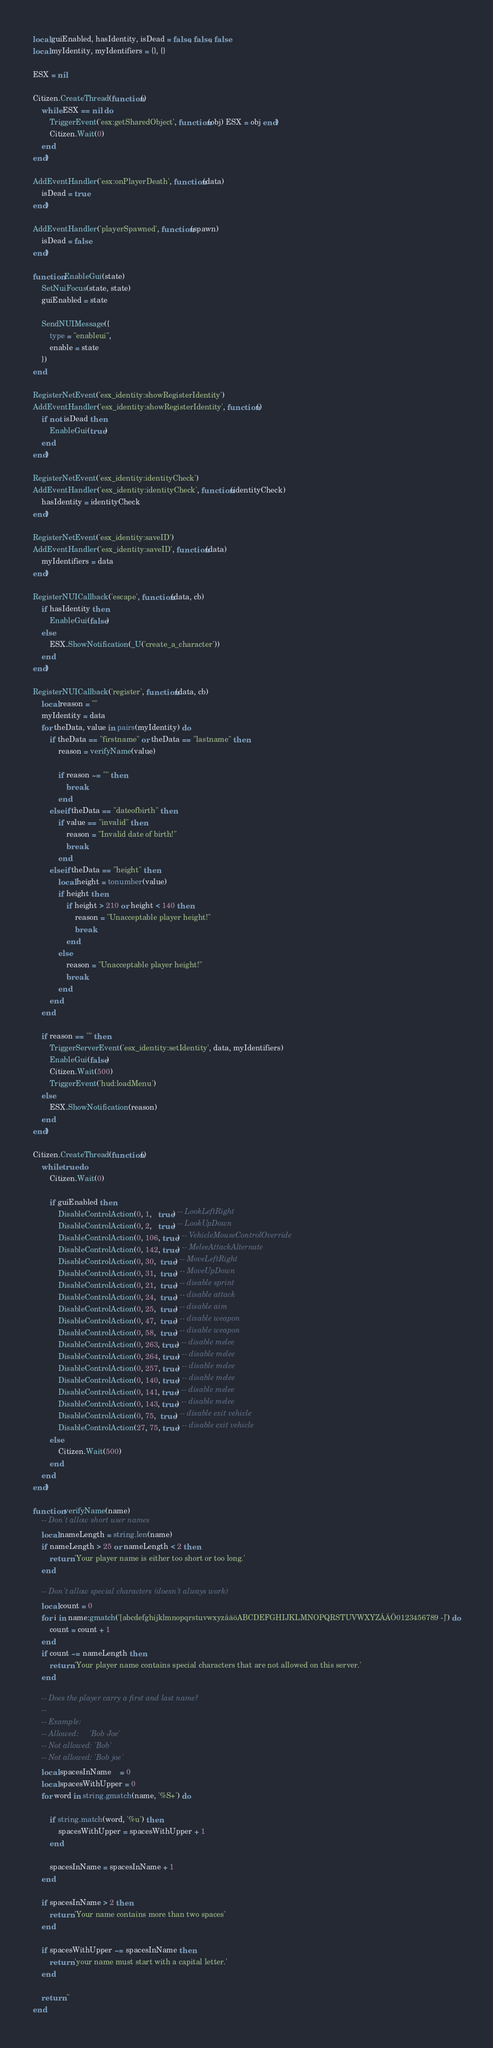<code> <loc_0><loc_0><loc_500><loc_500><_Lua_>local guiEnabled, hasIdentity, isDead = false, false, false
local myIdentity, myIdentifiers = {}, {}

ESX = nil

Citizen.CreateThread(function()
	while ESX == nil do
		TriggerEvent('esx:getSharedObject', function(obj) ESX = obj end)
		Citizen.Wait(0)
	end
end)

AddEventHandler('esx:onPlayerDeath', function(data)
	isDead = true
end)

AddEventHandler('playerSpawned', function(spawn)
	isDead = false
end)

function EnableGui(state)
	SetNuiFocus(state, state)
	guiEnabled = state

	SendNUIMessage({
		type = "enableui",
		enable = state
	})
end

RegisterNetEvent('esx_identity:showRegisterIdentity')
AddEventHandler('esx_identity:showRegisterIdentity', function()
	if not isDead then
		EnableGui(true)
	end
end)

RegisterNetEvent('esx_identity:identityCheck')
AddEventHandler('esx_identity:identityCheck', function(identityCheck)
	hasIdentity = identityCheck
end)

RegisterNetEvent('esx_identity:saveID')
AddEventHandler('esx_identity:saveID', function(data)
	myIdentifiers = data
end)

RegisterNUICallback('escape', function(data, cb)
	if hasIdentity then
		EnableGui(false)
	else
		ESX.ShowNotification(_U('create_a_character'))
	end
end)

RegisterNUICallback('register', function(data, cb)
	local reason = ""
	myIdentity = data
	for theData, value in pairs(myIdentity) do
		if theData == "firstname" or theData == "lastname" then
			reason = verifyName(value)
			
			if reason ~= "" then
				break
			end
		elseif theData == "dateofbirth" then
			if value == "invalid" then
				reason = "Invalid date of birth!"
				break
			end
		elseif theData == "height" then
			local height = tonumber(value)
			if height then
				if height > 210 or height < 140 then
					reason = "Unacceptable player height!"
					break
				end
			else
				reason = "Unacceptable player height!"
				break
			end
		end
	end
	
	if reason == "" then
		TriggerServerEvent('esx_identity:setIdentity', data, myIdentifiers)
		EnableGui(false)
		Citizen.Wait(500)
		TriggerEvent('hud:loadMenu')
	else
		ESX.ShowNotification(reason)
	end
end)

Citizen.CreateThread(function()
	while true do
		Citizen.Wait(0)

		if guiEnabled then
			DisableControlAction(0, 1,   true) -- LookLeftRight
			DisableControlAction(0, 2,   true) -- LookUpDown
			DisableControlAction(0, 106, true) -- VehicleMouseControlOverride
			DisableControlAction(0, 142, true) -- MeleeAttackAlternate
			DisableControlAction(0, 30,  true) -- MoveLeftRight
			DisableControlAction(0, 31,  true) -- MoveUpDown
			DisableControlAction(0, 21,  true) -- disable sprint
			DisableControlAction(0, 24,  true) -- disable attack
			DisableControlAction(0, 25,  true) -- disable aim
			DisableControlAction(0, 47,  true) -- disable weapon
			DisableControlAction(0, 58,  true) -- disable weapon
			DisableControlAction(0, 263, true) -- disable melee
			DisableControlAction(0, 264, true) -- disable melee
			DisableControlAction(0, 257, true) -- disable melee
			DisableControlAction(0, 140, true) -- disable melee
			DisableControlAction(0, 141, true) -- disable melee
			DisableControlAction(0, 143, true) -- disable melee
			DisableControlAction(0, 75,  true) -- disable exit vehicle
			DisableControlAction(27, 75, true) -- disable exit vehicle
		else
			Citizen.Wait(500)
		end
	end
end)

function verifyName(name)
	-- Don't allow short user names
	local nameLength = string.len(name)
	if nameLength > 25 or nameLength < 2 then
		return 'Your player name is either too short or too long.'
	end
	
	-- Don't allow special characters (doesn't always work)
	local count = 0
	for i in name:gmatch('[abcdefghijklmnopqrstuvwxyzåäöABCDEFGHIJKLMNOPQRSTUVWXYZÅÄÖ0123456789 -]') do
		count = count + 1
	end
	if count ~= nameLength then
		return 'Your player name contains special characters that are not allowed on this server.'
	end
	
	-- Does the player carry a first and last name?
	-- 
	-- Example:
	-- Allowed:     'Bob Joe'
	-- Not allowed: 'Bob'
	-- Not allowed: 'Bob joe'
	local spacesInName    = 0
	local spacesWithUpper = 0
	for word in string.gmatch(name, '%S+') do

		if string.match(word, '%u') then
			spacesWithUpper = spacesWithUpper + 1
		end

		spacesInName = spacesInName + 1
	end

	if spacesInName > 2 then
		return 'Your name contains more than two spaces'
	end
	
	if spacesWithUpper ~= spacesInName then
		return 'your name must start with a capital letter.'
	end

	return ''
end
</code> 